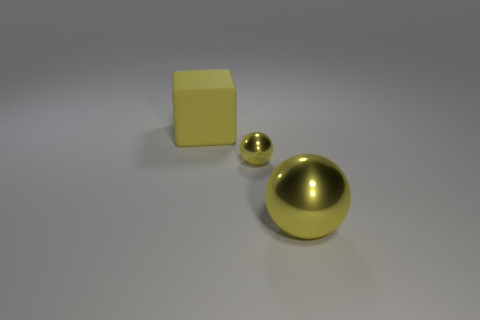Are there any other things that are the same shape as the yellow rubber object?
Provide a short and direct response. No. What number of other things are there of the same size as the matte thing?
Provide a succinct answer. 1. What size is the yellow thing that is left of the tiny metal object?
Provide a short and direct response. Large. Is there any other thing that has the same color as the rubber block?
Make the answer very short. Yes. Is the material of the large object that is on the right side of the yellow block the same as the yellow block?
Ensure brevity in your answer.  No. What number of yellow things are both behind the large yellow shiny object and in front of the yellow rubber object?
Give a very brief answer. 1. What size is the metal ball behind the big object right of the big matte thing?
Provide a succinct answer. Small. Are there any other things that have the same material as the big ball?
Offer a terse response. Yes. Is the number of large yellow matte objects greater than the number of large green metal cubes?
Keep it short and to the point. Yes. Does the object behind the small yellow ball have the same color as the metal sphere that is in front of the tiny metallic object?
Provide a short and direct response. Yes. 